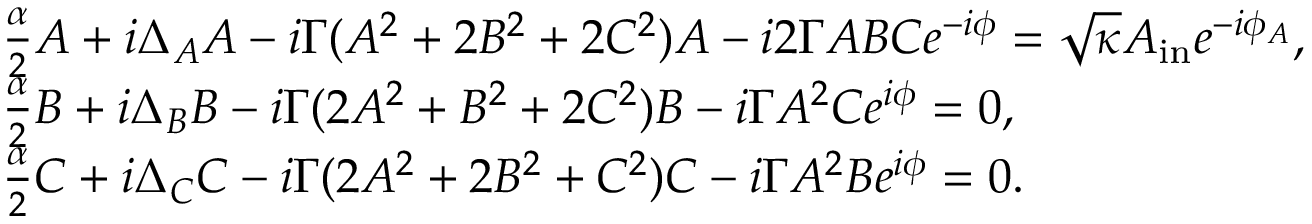Convert formula to latex. <formula><loc_0><loc_0><loc_500><loc_500>\begin{array} { r l } & { \frac { \alpha } { 2 } A + i \Delta _ { A } A - i \Gamma ( A ^ { 2 } + 2 B ^ { 2 } + 2 C ^ { 2 } ) A - i 2 \Gamma A B C e ^ { - i \phi } = \sqrt { \kappa } A _ { i n } e ^ { - i \phi _ { A } } , } \\ & { \frac { \alpha } { 2 } B + i \Delta _ { B } B - i \Gamma ( 2 A ^ { 2 } + B ^ { 2 } + 2 C ^ { 2 } ) B - i \Gamma A ^ { 2 } C e ^ { i \phi } = 0 , } \\ & { \frac { \alpha } { 2 } C + i \Delta _ { C } C - i \Gamma ( 2 A ^ { 2 } + 2 B ^ { 2 } + C ^ { 2 } ) C - i \Gamma A ^ { 2 } B e ^ { i \phi } = 0 . } \end{array}</formula> 